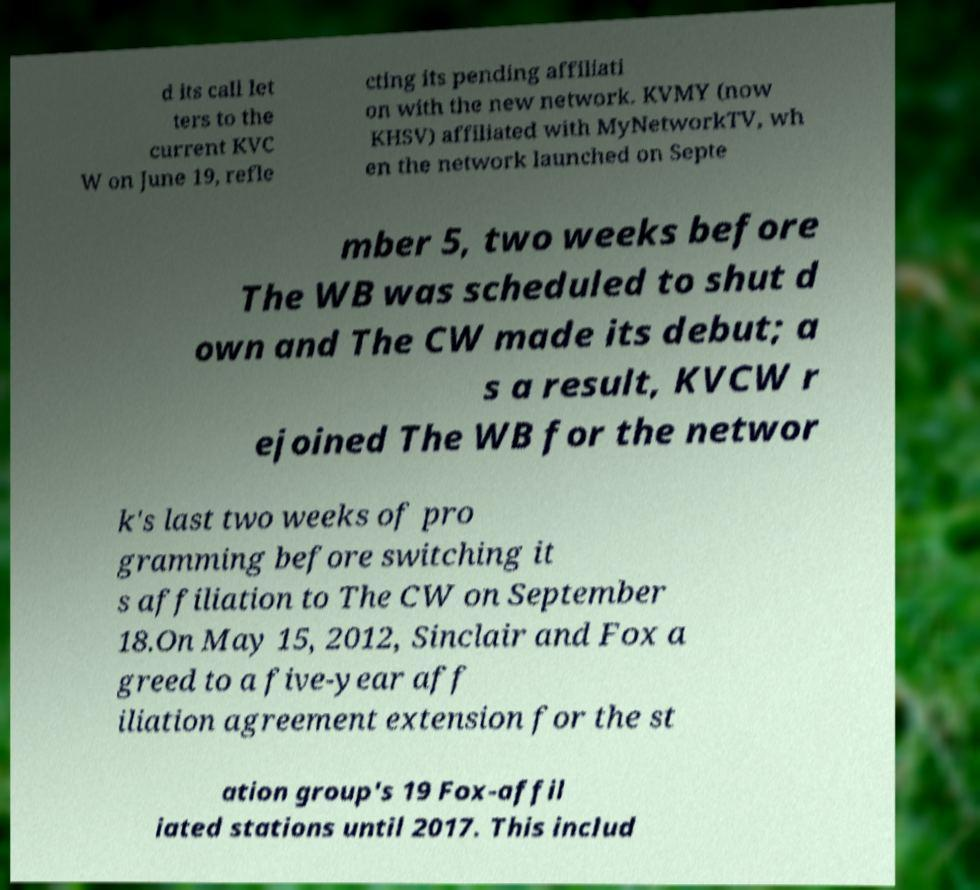Please read and relay the text visible in this image. What does it say? d its call let ters to the current KVC W on June 19, refle cting its pending affiliati on with the new network. KVMY (now KHSV) affiliated with MyNetworkTV, wh en the network launched on Septe mber 5, two weeks before The WB was scheduled to shut d own and The CW made its debut; a s a result, KVCW r ejoined The WB for the networ k's last two weeks of pro gramming before switching it s affiliation to The CW on September 18.On May 15, 2012, Sinclair and Fox a greed to a five-year aff iliation agreement extension for the st ation group's 19 Fox-affil iated stations until 2017. This includ 